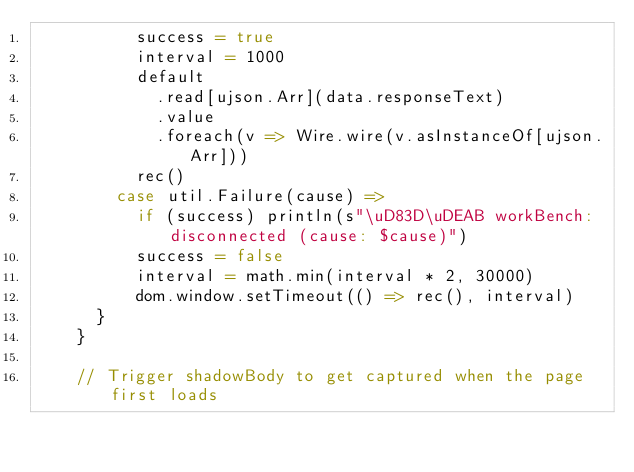<code> <loc_0><loc_0><loc_500><loc_500><_Scala_>          success = true
          interval = 1000
          default
            .read[ujson.Arr](data.responseText)
            .value
            .foreach(v => Wire.wire(v.asInstanceOf[ujson.Arr]))
          rec()
        case util.Failure(cause) =>
          if (success) println(s"\uD83D\uDEAB workBench: disconnected (cause: $cause)")
          success = false
          interval = math.min(interval * 2, 30000)
          dom.window.setTimeout(() => rec(), interval)
      }
    }

    // Trigger shadowBody to get captured when the page first loads</code> 